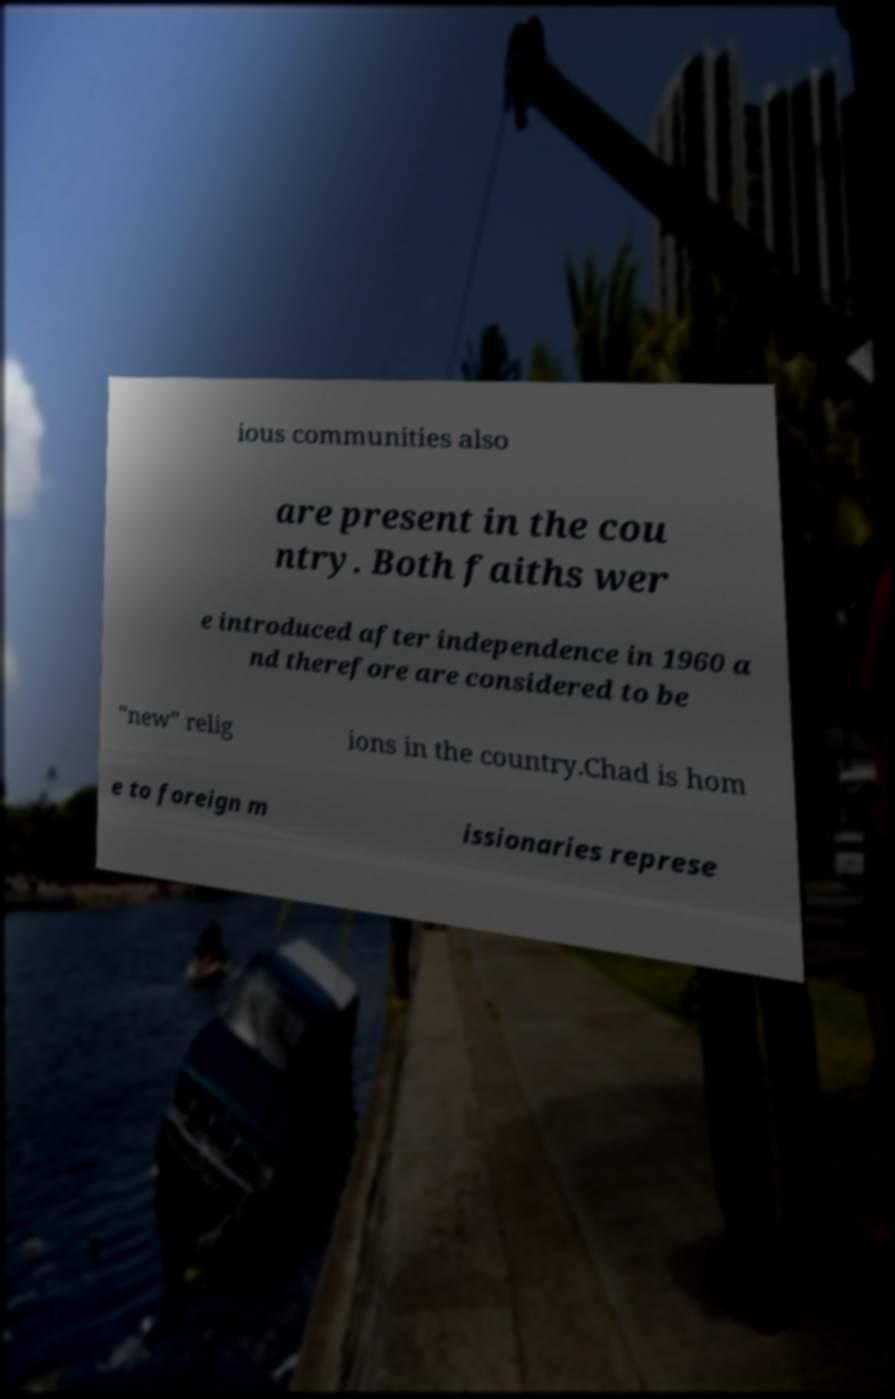Could you assist in decoding the text presented in this image and type it out clearly? ious communities also are present in the cou ntry. Both faiths wer e introduced after independence in 1960 a nd therefore are considered to be "new" relig ions in the country.Chad is hom e to foreign m issionaries represe 